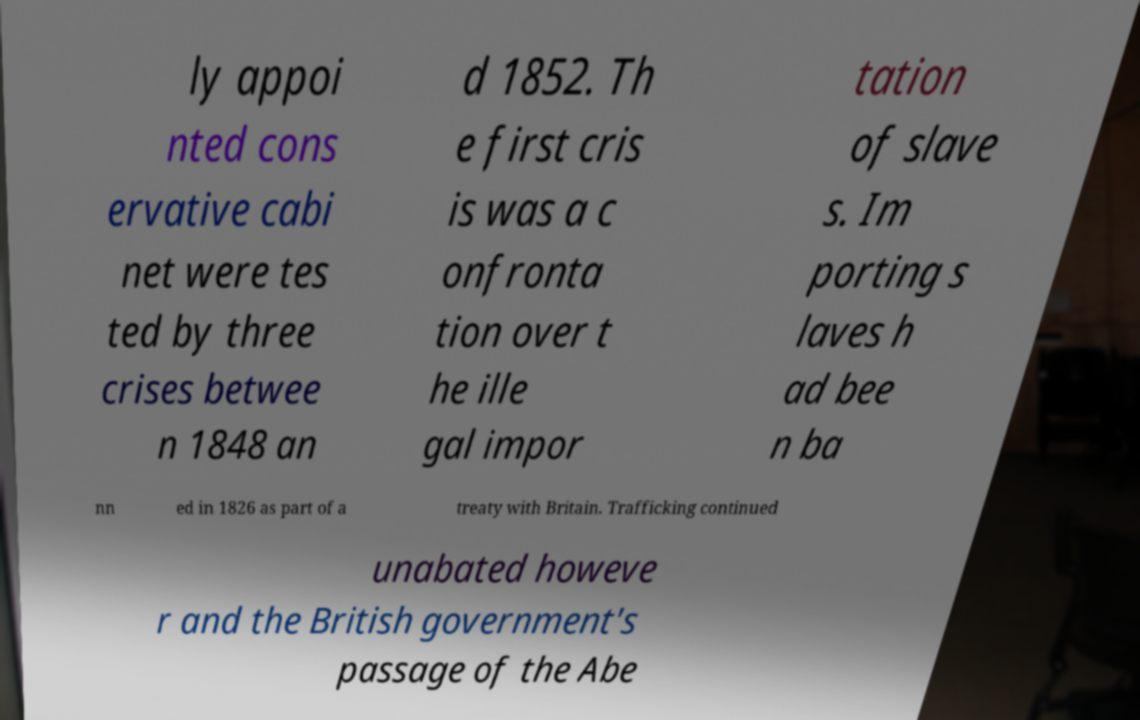Please read and relay the text visible in this image. What does it say? ly appoi nted cons ervative cabi net were tes ted by three crises betwee n 1848 an d 1852. Th e first cris is was a c onfronta tion over t he ille gal impor tation of slave s. Im porting s laves h ad bee n ba nn ed in 1826 as part of a treaty with Britain. Trafficking continued unabated howeve r and the British government's passage of the Abe 